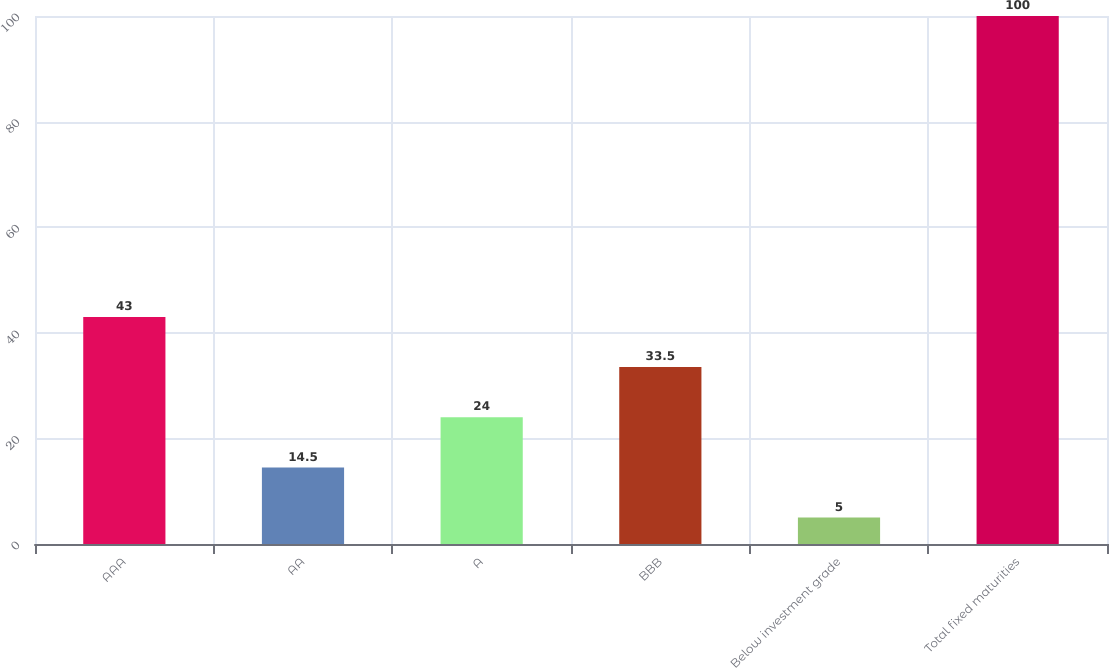<chart> <loc_0><loc_0><loc_500><loc_500><bar_chart><fcel>AAA<fcel>AA<fcel>A<fcel>BBB<fcel>Below investment grade<fcel>Total fixed maturities<nl><fcel>43<fcel>14.5<fcel>24<fcel>33.5<fcel>5<fcel>100<nl></chart> 